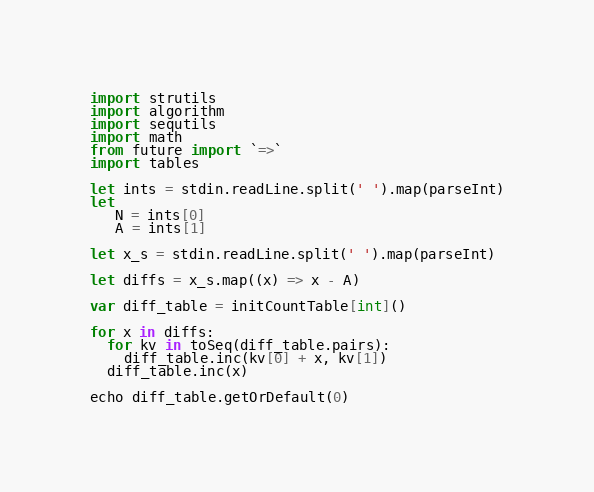Convert code to text. <code><loc_0><loc_0><loc_500><loc_500><_Nim_>import strutils
import algorithm
import sequtils
import math
from future import `=>`
import tables

let ints = stdin.readLine.split(' ').map(parseInt)
let 
   N = ints[0]
   A = ints[1]

let x_s = stdin.readLine.split(' ').map(parseInt)

let diffs = x_s.map((x) => x - A)

var diff_table = initCountTable[int]()

for x in diffs:
  for kv in toSeq(diff_table.pairs):
    diff_table.inc(kv[0] + x, kv[1])
  diff_table.inc(x)

echo diff_table.getOrDefault(0)
</code> 